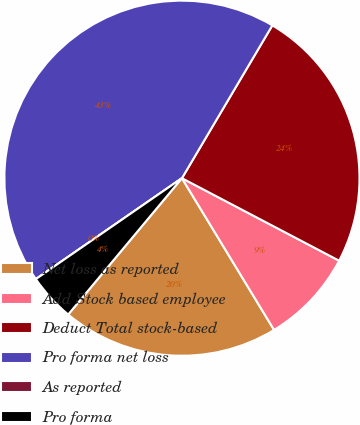Convert chart to OTSL. <chart><loc_0><loc_0><loc_500><loc_500><pie_chart><fcel>Net loss as reported<fcel>Add Stock based employee<fcel>Deduct Total stock-based<fcel>Pro forma net loss<fcel>As reported<fcel>Pro forma<nl><fcel>19.75%<fcel>8.62%<fcel>24.19%<fcel>43.12%<fcel>0.0%<fcel>4.31%<nl></chart> 